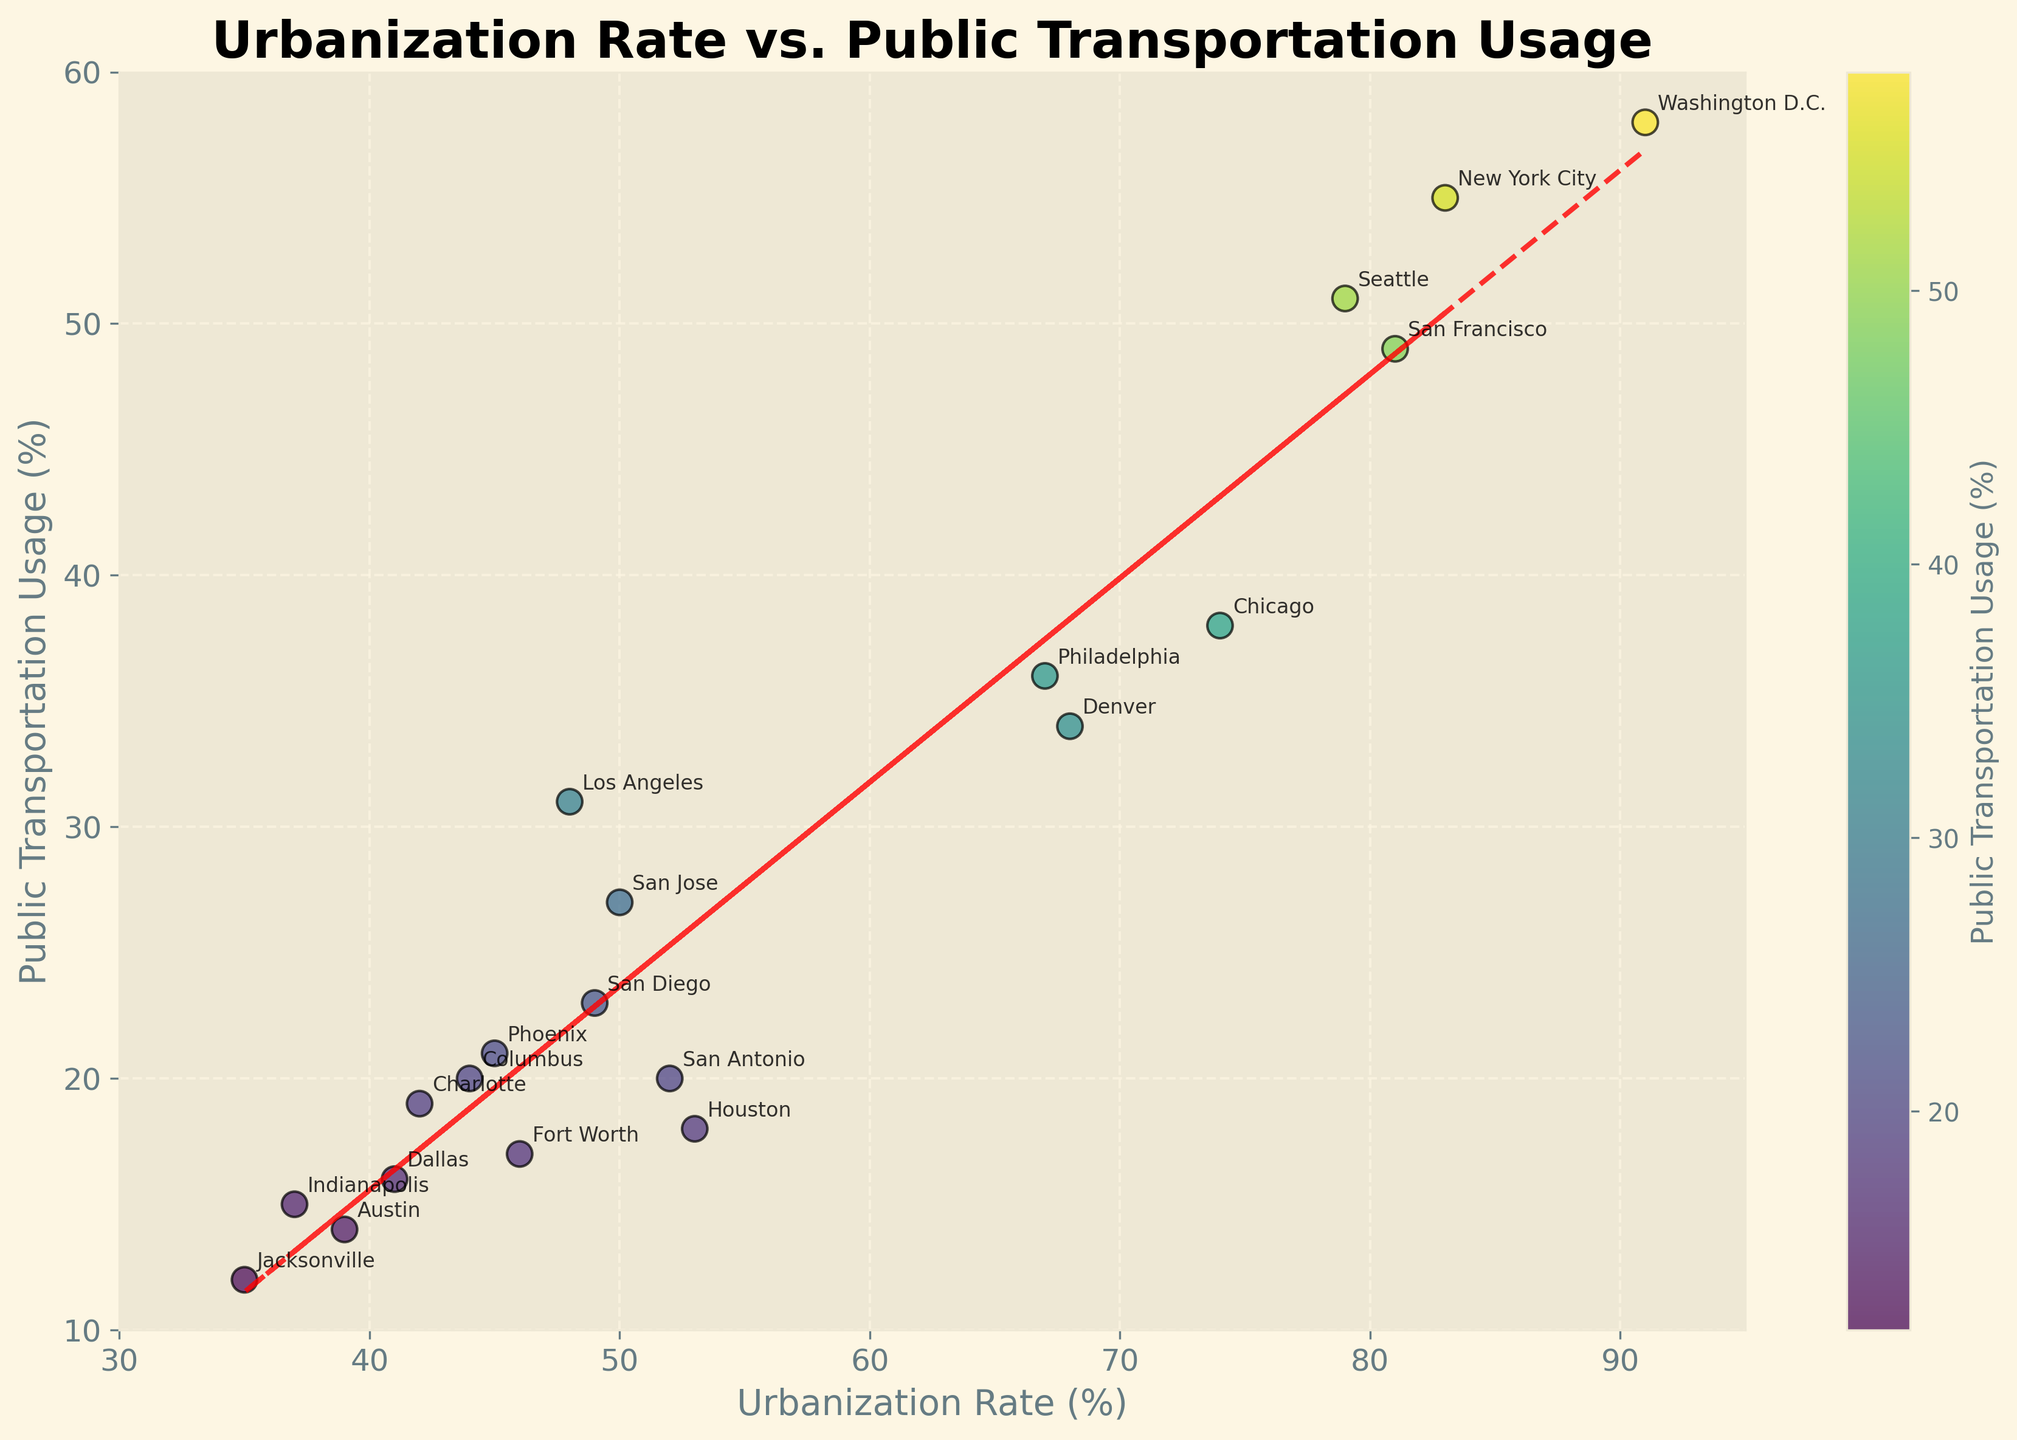What's the title of the figure? The title is displayed at the top of the figure in large, bold font.
Answer: Urbanization Rate vs. Public Transportation Usage How many data points are represented in the scatter plot? Count the number of unique city labels or data points on the scatter plot.
Answer: 20 Which city has the highest public transportation usage and what is its urbanization rate? Identify the data point with the highest y-value and read its corresponding x-value and city label.
Answer: Washington D.C., 91% What is the relationship between urbanization rate and public transportation usage based on the trend line? The trend line (red dashed line) shows whether there is a positive or negative relationship by its slope.
Answer: Positive relationship Which city has the lowest public transportation usage? Identify the data point with the lowest y-value and read its corresponding city label.
Answer: Jacksonville How does the public transportation usage in New York City compare to Los Angeles? Find the y-values for both New York City and Los Angeles and compare them.
Answer: New York City has higher public transportation usage (55% vs. 31%) What is the urbanization rate range of the cities in the scatter plot? Identify the smallest and largest x-values on the plot.
Answer: 35% to 91% Which city appears to be an outlier with a high urbanization rate but lower public transportation usage? Look for the data point with a high x-value but relatively low y-value compared to the trend line.
Answer: Los Angeles Is there a city with an urbanization rate between 60% and 70%? If yes, name it and state its public transportation usage. Find data points within the x-value range of 60% to 70% and read the corresponding city label and y-value.
Answer: Philadelphia, 36% Calculate the average public transportation usage of cities with urbanization rates above 50%. Identify data points with x-values higher than 50%, sum their y-values, and divide by the number of such data points. (55+38+58+34+20+49+27) / 7 = 39.571
Answer: 39.571 